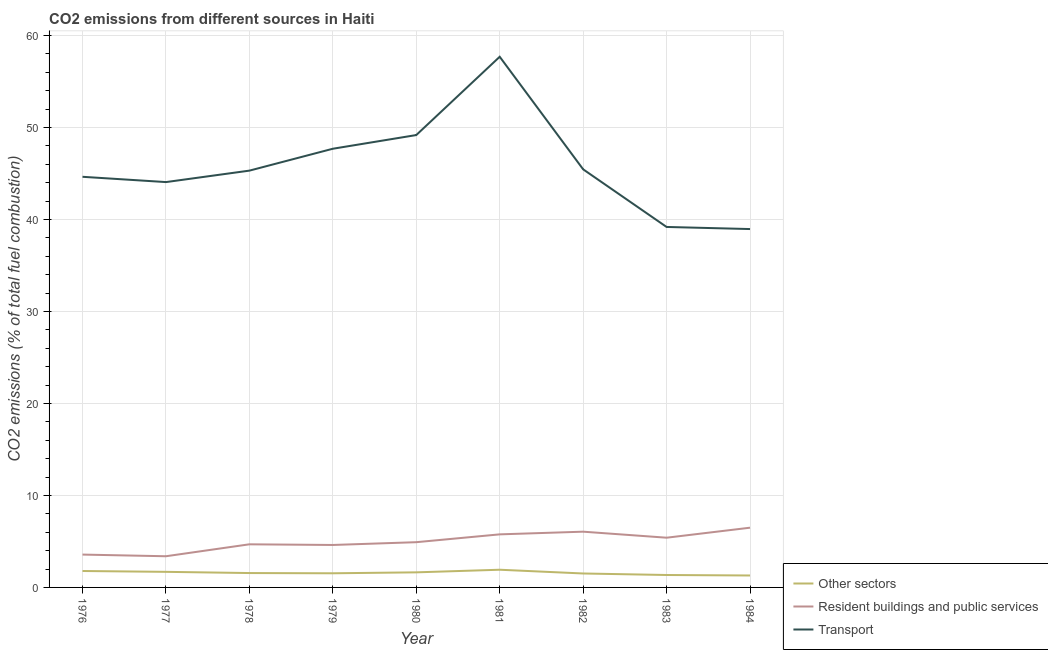Does the line corresponding to percentage of co2 emissions from other sectors intersect with the line corresponding to percentage of co2 emissions from resident buildings and public services?
Your response must be concise. No. What is the percentage of co2 emissions from other sectors in 1983?
Ensure brevity in your answer.  1.35. Across all years, what is the maximum percentage of co2 emissions from other sectors?
Your answer should be compact. 1.92. Across all years, what is the minimum percentage of co2 emissions from resident buildings and public services?
Provide a succinct answer. 3.39. In which year was the percentage of co2 emissions from resident buildings and public services maximum?
Make the answer very short. 1984. What is the total percentage of co2 emissions from other sectors in the graph?
Offer a terse response. 14.31. What is the difference between the percentage of co2 emissions from other sectors in 1977 and that in 1980?
Your answer should be very brief. 0.06. What is the difference between the percentage of co2 emissions from resident buildings and public services in 1983 and the percentage of co2 emissions from transport in 1977?
Give a very brief answer. -38.66. What is the average percentage of co2 emissions from transport per year?
Offer a very short reply. 45.8. In the year 1982, what is the difference between the percentage of co2 emissions from resident buildings and public services and percentage of co2 emissions from transport?
Give a very brief answer. -39.39. In how many years, is the percentage of co2 emissions from transport greater than 42 %?
Your answer should be compact. 7. What is the ratio of the percentage of co2 emissions from resident buildings and public services in 1976 to that in 1980?
Your answer should be compact. 0.73. Is the percentage of co2 emissions from resident buildings and public services in 1976 less than that in 1981?
Ensure brevity in your answer.  Yes. What is the difference between the highest and the second highest percentage of co2 emissions from resident buildings and public services?
Your response must be concise. 0.43. What is the difference between the highest and the lowest percentage of co2 emissions from transport?
Your response must be concise. 18.73. In how many years, is the percentage of co2 emissions from transport greater than the average percentage of co2 emissions from transport taken over all years?
Keep it short and to the point. 3. Is the sum of the percentage of co2 emissions from resident buildings and public services in 1976 and 1978 greater than the maximum percentage of co2 emissions from other sectors across all years?
Your response must be concise. Yes. Is the percentage of co2 emissions from transport strictly greater than the percentage of co2 emissions from resident buildings and public services over the years?
Provide a short and direct response. Yes. Is the percentage of co2 emissions from resident buildings and public services strictly less than the percentage of co2 emissions from other sectors over the years?
Keep it short and to the point. No. Where does the legend appear in the graph?
Make the answer very short. Bottom right. How many legend labels are there?
Offer a very short reply. 3. What is the title of the graph?
Ensure brevity in your answer.  CO2 emissions from different sources in Haiti. What is the label or title of the Y-axis?
Your answer should be compact. CO2 emissions (% of total fuel combustion). What is the CO2 emissions (% of total fuel combustion) in Other sectors in 1976?
Offer a very short reply. 1.79. What is the CO2 emissions (% of total fuel combustion) in Resident buildings and public services in 1976?
Keep it short and to the point. 3.57. What is the CO2 emissions (% of total fuel combustion) in Transport in 1976?
Give a very brief answer. 44.64. What is the CO2 emissions (% of total fuel combustion) in Other sectors in 1977?
Your response must be concise. 1.69. What is the CO2 emissions (% of total fuel combustion) in Resident buildings and public services in 1977?
Offer a terse response. 3.39. What is the CO2 emissions (% of total fuel combustion) in Transport in 1977?
Ensure brevity in your answer.  44.07. What is the CO2 emissions (% of total fuel combustion) in Other sectors in 1978?
Your response must be concise. 1.56. What is the CO2 emissions (% of total fuel combustion) of Resident buildings and public services in 1978?
Ensure brevity in your answer.  4.69. What is the CO2 emissions (% of total fuel combustion) in Transport in 1978?
Ensure brevity in your answer.  45.31. What is the CO2 emissions (% of total fuel combustion) of Other sectors in 1979?
Your answer should be very brief. 1.54. What is the CO2 emissions (% of total fuel combustion) of Resident buildings and public services in 1979?
Provide a short and direct response. 4.62. What is the CO2 emissions (% of total fuel combustion) of Transport in 1979?
Keep it short and to the point. 47.69. What is the CO2 emissions (% of total fuel combustion) in Other sectors in 1980?
Offer a terse response. 1.64. What is the CO2 emissions (% of total fuel combustion) in Resident buildings and public services in 1980?
Provide a short and direct response. 4.92. What is the CO2 emissions (% of total fuel combustion) of Transport in 1980?
Your response must be concise. 49.18. What is the CO2 emissions (% of total fuel combustion) in Other sectors in 1981?
Give a very brief answer. 1.92. What is the CO2 emissions (% of total fuel combustion) of Resident buildings and public services in 1981?
Make the answer very short. 5.77. What is the CO2 emissions (% of total fuel combustion) of Transport in 1981?
Your answer should be compact. 57.69. What is the CO2 emissions (% of total fuel combustion) of Other sectors in 1982?
Offer a very short reply. 1.52. What is the CO2 emissions (% of total fuel combustion) of Resident buildings and public services in 1982?
Ensure brevity in your answer.  6.06. What is the CO2 emissions (% of total fuel combustion) of Transport in 1982?
Your response must be concise. 45.45. What is the CO2 emissions (% of total fuel combustion) of Other sectors in 1983?
Offer a very short reply. 1.35. What is the CO2 emissions (% of total fuel combustion) of Resident buildings and public services in 1983?
Make the answer very short. 5.41. What is the CO2 emissions (% of total fuel combustion) of Transport in 1983?
Make the answer very short. 39.19. What is the CO2 emissions (% of total fuel combustion) in Other sectors in 1984?
Offer a terse response. 1.3. What is the CO2 emissions (% of total fuel combustion) of Resident buildings and public services in 1984?
Give a very brief answer. 6.49. What is the CO2 emissions (% of total fuel combustion) in Transport in 1984?
Give a very brief answer. 38.96. Across all years, what is the maximum CO2 emissions (% of total fuel combustion) in Other sectors?
Your response must be concise. 1.92. Across all years, what is the maximum CO2 emissions (% of total fuel combustion) in Resident buildings and public services?
Give a very brief answer. 6.49. Across all years, what is the maximum CO2 emissions (% of total fuel combustion) in Transport?
Provide a succinct answer. 57.69. Across all years, what is the minimum CO2 emissions (% of total fuel combustion) of Other sectors?
Ensure brevity in your answer.  1.3. Across all years, what is the minimum CO2 emissions (% of total fuel combustion) in Resident buildings and public services?
Give a very brief answer. 3.39. Across all years, what is the minimum CO2 emissions (% of total fuel combustion) of Transport?
Give a very brief answer. 38.96. What is the total CO2 emissions (% of total fuel combustion) of Other sectors in the graph?
Your answer should be very brief. 14.31. What is the total CO2 emissions (% of total fuel combustion) of Resident buildings and public services in the graph?
Provide a short and direct response. 44.91. What is the total CO2 emissions (% of total fuel combustion) of Transport in the graph?
Your response must be concise. 412.19. What is the difference between the CO2 emissions (% of total fuel combustion) in Other sectors in 1976 and that in 1977?
Offer a very short reply. 0.09. What is the difference between the CO2 emissions (% of total fuel combustion) of Resident buildings and public services in 1976 and that in 1977?
Keep it short and to the point. 0.18. What is the difference between the CO2 emissions (% of total fuel combustion) of Transport in 1976 and that in 1977?
Give a very brief answer. 0.58. What is the difference between the CO2 emissions (% of total fuel combustion) of Other sectors in 1976 and that in 1978?
Keep it short and to the point. 0.22. What is the difference between the CO2 emissions (% of total fuel combustion) of Resident buildings and public services in 1976 and that in 1978?
Provide a succinct answer. -1.12. What is the difference between the CO2 emissions (% of total fuel combustion) of Transport in 1976 and that in 1978?
Your answer should be compact. -0.67. What is the difference between the CO2 emissions (% of total fuel combustion) of Other sectors in 1976 and that in 1979?
Ensure brevity in your answer.  0.25. What is the difference between the CO2 emissions (% of total fuel combustion) in Resident buildings and public services in 1976 and that in 1979?
Provide a succinct answer. -1.04. What is the difference between the CO2 emissions (% of total fuel combustion) of Transport in 1976 and that in 1979?
Make the answer very short. -3.05. What is the difference between the CO2 emissions (% of total fuel combustion) in Other sectors in 1976 and that in 1980?
Your response must be concise. 0.15. What is the difference between the CO2 emissions (% of total fuel combustion) of Resident buildings and public services in 1976 and that in 1980?
Make the answer very short. -1.35. What is the difference between the CO2 emissions (% of total fuel combustion) in Transport in 1976 and that in 1980?
Give a very brief answer. -4.54. What is the difference between the CO2 emissions (% of total fuel combustion) in Other sectors in 1976 and that in 1981?
Make the answer very short. -0.14. What is the difference between the CO2 emissions (% of total fuel combustion) of Resident buildings and public services in 1976 and that in 1981?
Your response must be concise. -2.2. What is the difference between the CO2 emissions (% of total fuel combustion) in Transport in 1976 and that in 1981?
Provide a succinct answer. -13.05. What is the difference between the CO2 emissions (% of total fuel combustion) in Other sectors in 1976 and that in 1982?
Keep it short and to the point. 0.27. What is the difference between the CO2 emissions (% of total fuel combustion) of Resident buildings and public services in 1976 and that in 1982?
Offer a terse response. -2.49. What is the difference between the CO2 emissions (% of total fuel combustion) in Transport in 1976 and that in 1982?
Your answer should be compact. -0.81. What is the difference between the CO2 emissions (% of total fuel combustion) of Other sectors in 1976 and that in 1983?
Give a very brief answer. 0.43. What is the difference between the CO2 emissions (% of total fuel combustion) in Resident buildings and public services in 1976 and that in 1983?
Offer a terse response. -1.83. What is the difference between the CO2 emissions (% of total fuel combustion) of Transport in 1976 and that in 1983?
Make the answer very short. 5.45. What is the difference between the CO2 emissions (% of total fuel combustion) in Other sectors in 1976 and that in 1984?
Give a very brief answer. 0.49. What is the difference between the CO2 emissions (% of total fuel combustion) of Resident buildings and public services in 1976 and that in 1984?
Provide a succinct answer. -2.92. What is the difference between the CO2 emissions (% of total fuel combustion) of Transport in 1976 and that in 1984?
Offer a very short reply. 5.68. What is the difference between the CO2 emissions (% of total fuel combustion) in Other sectors in 1977 and that in 1978?
Provide a short and direct response. 0.13. What is the difference between the CO2 emissions (% of total fuel combustion) of Resident buildings and public services in 1977 and that in 1978?
Offer a very short reply. -1.3. What is the difference between the CO2 emissions (% of total fuel combustion) of Transport in 1977 and that in 1978?
Make the answer very short. -1.24. What is the difference between the CO2 emissions (% of total fuel combustion) in Other sectors in 1977 and that in 1979?
Your answer should be compact. 0.16. What is the difference between the CO2 emissions (% of total fuel combustion) in Resident buildings and public services in 1977 and that in 1979?
Provide a short and direct response. -1.23. What is the difference between the CO2 emissions (% of total fuel combustion) of Transport in 1977 and that in 1979?
Your response must be concise. -3.62. What is the difference between the CO2 emissions (% of total fuel combustion) in Other sectors in 1977 and that in 1980?
Your answer should be very brief. 0.06. What is the difference between the CO2 emissions (% of total fuel combustion) of Resident buildings and public services in 1977 and that in 1980?
Offer a terse response. -1.53. What is the difference between the CO2 emissions (% of total fuel combustion) of Transport in 1977 and that in 1980?
Keep it short and to the point. -5.11. What is the difference between the CO2 emissions (% of total fuel combustion) in Other sectors in 1977 and that in 1981?
Provide a succinct answer. -0.23. What is the difference between the CO2 emissions (% of total fuel combustion) of Resident buildings and public services in 1977 and that in 1981?
Ensure brevity in your answer.  -2.38. What is the difference between the CO2 emissions (% of total fuel combustion) in Transport in 1977 and that in 1981?
Offer a terse response. -13.62. What is the difference between the CO2 emissions (% of total fuel combustion) of Other sectors in 1977 and that in 1982?
Provide a succinct answer. 0.18. What is the difference between the CO2 emissions (% of total fuel combustion) in Resident buildings and public services in 1977 and that in 1982?
Your response must be concise. -2.67. What is the difference between the CO2 emissions (% of total fuel combustion) of Transport in 1977 and that in 1982?
Provide a succinct answer. -1.39. What is the difference between the CO2 emissions (% of total fuel combustion) of Other sectors in 1977 and that in 1983?
Your response must be concise. 0.34. What is the difference between the CO2 emissions (% of total fuel combustion) of Resident buildings and public services in 1977 and that in 1983?
Make the answer very short. -2.02. What is the difference between the CO2 emissions (% of total fuel combustion) of Transport in 1977 and that in 1983?
Your answer should be compact. 4.88. What is the difference between the CO2 emissions (% of total fuel combustion) in Other sectors in 1977 and that in 1984?
Give a very brief answer. 0.4. What is the difference between the CO2 emissions (% of total fuel combustion) of Resident buildings and public services in 1977 and that in 1984?
Ensure brevity in your answer.  -3.1. What is the difference between the CO2 emissions (% of total fuel combustion) in Transport in 1977 and that in 1984?
Offer a terse response. 5.11. What is the difference between the CO2 emissions (% of total fuel combustion) of Other sectors in 1978 and that in 1979?
Give a very brief answer. 0.02. What is the difference between the CO2 emissions (% of total fuel combustion) of Resident buildings and public services in 1978 and that in 1979?
Offer a terse response. 0.07. What is the difference between the CO2 emissions (% of total fuel combustion) of Transport in 1978 and that in 1979?
Give a very brief answer. -2.38. What is the difference between the CO2 emissions (% of total fuel combustion) in Other sectors in 1978 and that in 1980?
Provide a succinct answer. -0.08. What is the difference between the CO2 emissions (% of total fuel combustion) of Resident buildings and public services in 1978 and that in 1980?
Offer a very short reply. -0.23. What is the difference between the CO2 emissions (% of total fuel combustion) in Transport in 1978 and that in 1980?
Make the answer very short. -3.87. What is the difference between the CO2 emissions (% of total fuel combustion) in Other sectors in 1978 and that in 1981?
Ensure brevity in your answer.  -0.36. What is the difference between the CO2 emissions (% of total fuel combustion) of Resident buildings and public services in 1978 and that in 1981?
Your answer should be very brief. -1.08. What is the difference between the CO2 emissions (% of total fuel combustion) in Transport in 1978 and that in 1981?
Keep it short and to the point. -12.38. What is the difference between the CO2 emissions (% of total fuel combustion) in Other sectors in 1978 and that in 1982?
Make the answer very short. 0.05. What is the difference between the CO2 emissions (% of total fuel combustion) in Resident buildings and public services in 1978 and that in 1982?
Ensure brevity in your answer.  -1.37. What is the difference between the CO2 emissions (% of total fuel combustion) of Transport in 1978 and that in 1982?
Offer a very short reply. -0.14. What is the difference between the CO2 emissions (% of total fuel combustion) in Other sectors in 1978 and that in 1983?
Provide a succinct answer. 0.21. What is the difference between the CO2 emissions (% of total fuel combustion) in Resident buildings and public services in 1978 and that in 1983?
Ensure brevity in your answer.  -0.72. What is the difference between the CO2 emissions (% of total fuel combustion) in Transport in 1978 and that in 1983?
Offer a very short reply. 6.12. What is the difference between the CO2 emissions (% of total fuel combustion) in Other sectors in 1978 and that in 1984?
Make the answer very short. 0.26. What is the difference between the CO2 emissions (% of total fuel combustion) in Resident buildings and public services in 1978 and that in 1984?
Your answer should be compact. -1.81. What is the difference between the CO2 emissions (% of total fuel combustion) of Transport in 1978 and that in 1984?
Your response must be concise. 6.35. What is the difference between the CO2 emissions (% of total fuel combustion) of Other sectors in 1979 and that in 1980?
Provide a short and direct response. -0.1. What is the difference between the CO2 emissions (% of total fuel combustion) of Resident buildings and public services in 1979 and that in 1980?
Make the answer very short. -0.3. What is the difference between the CO2 emissions (% of total fuel combustion) of Transport in 1979 and that in 1980?
Your response must be concise. -1.49. What is the difference between the CO2 emissions (% of total fuel combustion) of Other sectors in 1979 and that in 1981?
Ensure brevity in your answer.  -0.38. What is the difference between the CO2 emissions (% of total fuel combustion) of Resident buildings and public services in 1979 and that in 1981?
Make the answer very short. -1.15. What is the difference between the CO2 emissions (% of total fuel combustion) in Other sectors in 1979 and that in 1982?
Offer a terse response. 0.02. What is the difference between the CO2 emissions (% of total fuel combustion) in Resident buildings and public services in 1979 and that in 1982?
Offer a terse response. -1.45. What is the difference between the CO2 emissions (% of total fuel combustion) of Transport in 1979 and that in 1982?
Keep it short and to the point. 2.24. What is the difference between the CO2 emissions (% of total fuel combustion) in Other sectors in 1979 and that in 1983?
Give a very brief answer. 0.19. What is the difference between the CO2 emissions (% of total fuel combustion) of Resident buildings and public services in 1979 and that in 1983?
Your answer should be very brief. -0.79. What is the difference between the CO2 emissions (% of total fuel combustion) of Transport in 1979 and that in 1983?
Offer a terse response. 8.5. What is the difference between the CO2 emissions (% of total fuel combustion) of Other sectors in 1979 and that in 1984?
Your answer should be compact. 0.24. What is the difference between the CO2 emissions (% of total fuel combustion) in Resident buildings and public services in 1979 and that in 1984?
Keep it short and to the point. -1.88. What is the difference between the CO2 emissions (% of total fuel combustion) of Transport in 1979 and that in 1984?
Ensure brevity in your answer.  8.73. What is the difference between the CO2 emissions (% of total fuel combustion) in Other sectors in 1980 and that in 1981?
Your response must be concise. -0.28. What is the difference between the CO2 emissions (% of total fuel combustion) in Resident buildings and public services in 1980 and that in 1981?
Provide a short and direct response. -0.85. What is the difference between the CO2 emissions (% of total fuel combustion) of Transport in 1980 and that in 1981?
Keep it short and to the point. -8.51. What is the difference between the CO2 emissions (% of total fuel combustion) in Other sectors in 1980 and that in 1982?
Keep it short and to the point. 0.12. What is the difference between the CO2 emissions (% of total fuel combustion) in Resident buildings and public services in 1980 and that in 1982?
Your response must be concise. -1.14. What is the difference between the CO2 emissions (% of total fuel combustion) of Transport in 1980 and that in 1982?
Give a very brief answer. 3.73. What is the difference between the CO2 emissions (% of total fuel combustion) of Other sectors in 1980 and that in 1983?
Your response must be concise. 0.29. What is the difference between the CO2 emissions (% of total fuel combustion) in Resident buildings and public services in 1980 and that in 1983?
Ensure brevity in your answer.  -0.49. What is the difference between the CO2 emissions (% of total fuel combustion) of Transport in 1980 and that in 1983?
Your response must be concise. 9.99. What is the difference between the CO2 emissions (% of total fuel combustion) of Other sectors in 1980 and that in 1984?
Offer a very short reply. 0.34. What is the difference between the CO2 emissions (% of total fuel combustion) of Resident buildings and public services in 1980 and that in 1984?
Provide a succinct answer. -1.58. What is the difference between the CO2 emissions (% of total fuel combustion) of Transport in 1980 and that in 1984?
Provide a succinct answer. 10.22. What is the difference between the CO2 emissions (% of total fuel combustion) of Other sectors in 1981 and that in 1982?
Give a very brief answer. 0.41. What is the difference between the CO2 emissions (% of total fuel combustion) in Resident buildings and public services in 1981 and that in 1982?
Ensure brevity in your answer.  -0.29. What is the difference between the CO2 emissions (% of total fuel combustion) in Transport in 1981 and that in 1982?
Your response must be concise. 12.24. What is the difference between the CO2 emissions (% of total fuel combustion) in Other sectors in 1981 and that in 1983?
Your answer should be very brief. 0.57. What is the difference between the CO2 emissions (% of total fuel combustion) in Resident buildings and public services in 1981 and that in 1983?
Give a very brief answer. 0.36. What is the difference between the CO2 emissions (% of total fuel combustion) in Transport in 1981 and that in 1983?
Provide a succinct answer. 18.5. What is the difference between the CO2 emissions (% of total fuel combustion) of Other sectors in 1981 and that in 1984?
Give a very brief answer. 0.62. What is the difference between the CO2 emissions (% of total fuel combustion) of Resident buildings and public services in 1981 and that in 1984?
Keep it short and to the point. -0.72. What is the difference between the CO2 emissions (% of total fuel combustion) in Transport in 1981 and that in 1984?
Offer a terse response. 18.73. What is the difference between the CO2 emissions (% of total fuel combustion) of Other sectors in 1982 and that in 1983?
Provide a succinct answer. 0.16. What is the difference between the CO2 emissions (% of total fuel combustion) in Resident buildings and public services in 1982 and that in 1983?
Offer a very short reply. 0.66. What is the difference between the CO2 emissions (% of total fuel combustion) of Transport in 1982 and that in 1983?
Your answer should be compact. 6.27. What is the difference between the CO2 emissions (% of total fuel combustion) of Other sectors in 1982 and that in 1984?
Your response must be concise. 0.22. What is the difference between the CO2 emissions (% of total fuel combustion) of Resident buildings and public services in 1982 and that in 1984?
Your answer should be compact. -0.43. What is the difference between the CO2 emissions (% of total fuel combustion) of Transport in 1982 and that in 1984?
Keep it short and to the point. 6.49. What is the difference between the CO2 emissions (% of total fuel combustion) of Other sectors in 1983 and that in 1984?
Offer a terse response. 0.05. What is the difference between the CO2 emissions (% of total fuel combustion) of Resident buildings and public services in 1983 and that in 1984?
Ensure brevity in your answer.  -1.09. What is the difference between the CO2 emissions (% of total fuel combustion) of Transport in 1983 and that in 1984?
Your answer should be compact. 0.23. What is the difference between the CO2 emissions (% of total fuel combustion) of Other sectors in 1976 and the CO2 emissions (% of total fuel combustion) of Resident buildings and public services in 1977?
Your answer should be very brief. -1.6. What is the difference between the CO2 emissions (% of total fuel combustion) in Other sectors in 1976 and the CO2 emissions (% of total fuel combustion) in Transport in 1977?
Your answer should be compact. -42.28. What is the difference between the CO2 emissions (% of total fuel combustion) of Resident buildings and public services in 1976 and the CO2 emissions (% of total fuel combustion) of Transport in 1977?
Your answer should be compact. -40.5. What is the difference between the CO2 emissions (% of total fuel combustion) in Other sectors in 1976 and the CO2 emissions (% of total fuel combustion) in Resident buildings and public services in 1978?
Your answer should be very brief. -2.9. What is the difference between the CO2 emissions (% of total fuel combustion) in Other sectors in 1976 and the CO2 emissions (% of total fuel combustion) in Transport in 1978?
Keep it short and to the point. -43.53. What is the difference between the CO2 emissions (% of total fuel combustion) in Resident buildings and public services in 1976 and the CO2 emissions (% of total fuel combustion) in Transport in 1978?
Give a very brief answer. -41.74. What is the difference between the CO2 emissions (% of total fuel combustion) in Other sectors in 1976 and the CO2 emissions (% of total fuel combustion) in Resident buildings and public services in 1979?
Keep it short and to the point. -2.83. What is the difference between the CO2 emissions (% of total fuel combustion) in Other sectors in 1976 and the CO2 emissions (% of total fuel combustion) in Transport in 1979?
Make the answer very short. -45.91. What is the difference between the CO2 emissions (% of total fuel combustion) in Resident buildings and public services in 1976 and the CO2 emissions (% of total fuel combustion) in Transport in 1979?
Your answer should be very brief. -44.12. What is the difference between the CO2 emissions (% of total fuel combustion) of Other sectors in 1976 and the CO2 emissions (% of total fuel combustion) of Resident buildings and public services in 1980?
Provide a short and direct response. -3.13. What is the difference between the CO2 emissions (% of total fuel combustion) of Other sectors in 1976 and the CO2 emissions (% of total fuel combustion) of Transport in 1980?
Ensure brevity in your answer.  -47.39. What is the difference between the CO2 emissions (% of total fuel combustion) in Resident buildings and public services in 1976 and the CO2 emissions (% of total fuel combustion) in Transport in 1980?
Provide a short and direct response. -45.61. What is the difference between the CO2 emissions (% of total fuel combustion) of Other sectors in 1976 and the CO2 emissions (% of total fuel combustion) of Resident buildings and public services in 1981?
Your answer should be very brief. -3.98. What is the difference between the CO2 emissions (% of total fuel combustion) of Other sectors in 1976 and the CO2 emissions (% of total fuel combustion) of Transport in 1981?
Offer a very short reply. -55.91. What is the difference between the CO2 emissions (% of total fuel combustion) in Resident buildings and public services in 1976 and the CO2 emissions (% of total fuel combustion) in Transport in 1981?
Keep it short and to the point. -54.12. What is the difference between the CO2 emissions (% of total fuel combustion) in Other sectors in 1976 and the CO2 emissions (% of total fuel combustion) in Resident buildings and public services in 1982?
Your answer should be compact. -4.27. What is the difference between the CO2 emissions (% of total fuel combustion) of Other sectors in 1976 and the CO2 emissions (% of total fuel combustion) of Transport in 1982?
Offer a terse response. -43.67. What is the difference between the CO2 emissions (% of total fuel combustion) in Resident buildings and public services in 1976 and the CO2 emissions (% of total fuel combustion) in Transport in 1982?
Your response must be concise. -41.88. What is the difference between the CO2 emissions (% of total fuel combustion) in Other sectors in 1976 and the CO2 emissions (% of total fuel combustion) in Resident buildings and public services in 1983?
Give a very brief answer. -3.62. What is the difference between the CO2 emissions (% of total fuel combustion) in Other sectors in 1976 and the CO2 emissions (% of total fuel combustion) in Transport in 1983?
Give a very brief answer. -37.4. What is the difference between the CO2 emissions (% of total fuel combustion) in Resident buildings and public services in 1976 and the CO2 emissions (% of total fuel combustion) in Transport in 1983?
Your response must be concise. -35.62. What is the difference between the CO2 emissions (% of total fuel combustion) of Other sectors in 1976 and the CO2 emissions (% of total fuel combustion) of Resident buildings and public services in 1984?
Provide a succinct answer. -4.71. What is the difference between the CO2 emissions (% of total fuel combustion) of Other sectors in 1976 and the CO2 emissions (% of total fuel combustion) of Transport in 1984?
Offer a very short reply. -37.18. What is the difference between the CO2 emissions (% of total fuel combustion) in Resident buildings and public services in 1976 and the CO2 emissions (% of total fuel combustion) in Transport in 1984?
Offer a terse response. -35.39. What is the difference between the CO2 emissions (% of total fuel combustion) of Other sectors in 1977 and the CO2 emissions (% of total fuel combustion) of Resident buildings and public services in 1978?
Give a very brief answer. -2.99. What is the difference between the CO2 emissions (% of total fuel combustion) in Other sectors in 1977 and the CO2 emissions (% of total fuel combustion) in Transport in 1978?
Your answer should be compact. -43.62. What is the difference between the CO2 emissions (% of total fuel combustion) in Resident buildings and public services in 1977 and the CO2 emissions (% of total fuel combustion) in Transport in 1978?
Offer a terse response. -41.92. What is the difference between the CO2 emissions (% of total fuel combustion) in Other sectors in 1977 and the CO2 emissions (% of total fuel combustion) in Resident buildings and public services in 1979?
Offer a terse response. -2.92. What is the difference between the CO2 emissions (% of total fuel combustion) of Other sectors in 1977 and the CO2 emissions (% of total fuel combustion) of Transport in 1979?
Give a very brief answer. -46. What is the difference between the CO2 emissions (% of total fuel combustion) in Resident buildings and public services in 1977 and the CO2 emissions (% of total fuel combustion) in Transport in 1979?
Offer a very short reply. -44.3. What is the difference between the CO2 emissions (% of total fuel combustion) in Other sectors in 1977 and the CO2 emissions (% of total fuel combustion) in Resident buildings and public services in 1980?
Your answer should be compact. -3.22. What is the difference between the CO2 emissions (% of total fuel combustion) in Other sectors in 1977 and the CO2 emissions (% of total fuel combustion) in Transport in 1980?
Ensure brevity in your answer.  -47.49. What is the difference between the CO2 emissions (% of total fuel combustion) in Resident buildings and public services in 1977 and the CO2 emissions (% of total fuel combustion) in Transport in 1980?
Provide a succinct answer. -45.79. What is the difference between the CO2 emissions (% of total fuel combustion) in Other sectors in 1977 and the CO2 emissions (% of total fuel combustion) in Resident buildings and public services in 1981?
Keep it short and to the point. -4.07. What is the difference between the CO2 emissions (% of total fuel combustion) in Other sectors in 1977 and the CO2 emissions (% of total fuel combustion) in Transport in 1981?
Offer a terse response. -56. What is the difference between the CO2 emissions (% of total fuel combustion) of Resident buildings and public services in 1977 and the CO2 emissions (% of total fuel combustion) of Transport in 1981?
Your answer should be compact. -54.3. What is the difference between the CO2 emissions (% of total fuel combustion) in Other sectors in 1977 and the CO2 emissions (% of total fuel combustion) in Resident buildings and public services in 1982?
Make the answer very short. -4.37. What is the difference between the CO2 emissions (% of total fuel combustion) in Other sectors in 1977 and the CO2 emissions (% of total fuel combustion) in Transport in 1982?
Offer a very short reply. -43.76. What is the difference between the CO2 emissions (% of total fuel combustion) of Resident buildings and public services in 1977 and the CO2 emissions (% of total fuel combustion) of Transport in 1982?
Provide a succinct answer. -42.06. What is the difference between the CO2 emissions (% of total fuel combustion) in Other sectors in 1977 and the CO2 emissions (% of total fuel combustion) in Resident buildings and public services in 1983?
Make the answer very short. -3.71. What is the difference between the CO2 emissions (% of total fuel combustion) of Other sectors in 1977 and the CO2 emissions (% of total fuel combustion) of Transport in 1983?
Provide a short and direct response. -37.49. What is the difference between the CO2 emissions (% of total fuel combustion) of Resident buildings and public services in 1977 and the CO2 emissions (% of total fuel combustion) of Transport in 1983?
Make the answer very short. -35.8. What is the difference between the CO2 emissions (% of total fuel combustion) in Other sectors in 1977 and the CO2 emissions (% of total fuel combustion) in Resident buildings and public services in 1984?
Give a very brief answer. -4.8. What is the difference between the CO2 emissions (% of total fuel combustion) in Other sectors in 1977 and the CO2 emissions (% of total fuel combustion) in Transport in 1984?
Your answer should be compact. -37.27. What is the difference between the CO2 emissions (% of total fuel combustion) in Resident buildings and public services in 1977 and the CO2 emissions (% of total fuel combustion) in Transport in 1984?
Give a very brief answer. -35.57. What is the difference between the CO2 emissions (% of total fuel combustion) of Other sectors in 1978 and the CO2 emissions (% of total fuel combustion) of Resident buildings and public services in 1979?
Make the answer very short. -3.05. What is the difference between the CO2 emissions (% of total fuel combustion) of Other sectors in 1978 and the CO2 emissions (% of total fuel combustion) of Transport in 1979?
Your response must be concise. -46.13. What is the difference between the CO2 emissions (% of total fuel combustion) of Resident buildings and public services in 1978 and the CO2 emissions (% of total fuel combustion) of Transport in 1979?
Keep it short and to the point. -43. What is the difference between the CO2 emissions (% of total fuel combustion) of Other sectors in 1978 and the CO2 emissions (% of total fuel combustion) of Resident buildings and public services in 1980?
Give a very brief answer. -3.36. What is the difference between the CO2 emissions (% of total fuel combustion) in Other sectors in 1978 and the CO2 emissions (% of total fuel combustion) in Transport in 1980?
Keep it short and to the point. -47.62. What is the difference between the CO2 emissions (% of total fuel combustion) of Resident buildings and public services in 1978 and the CO2 emissions (% of total fuel combustion) of Transport in 1980?
Your response must be concise. -44.49. What is the difference between the CO2 emissions (% of total fuel combustion) of Other sectors in 1978 and the CO2 emissions (% of total fuel combustion) of Resident buildings and public services in 1981?
Your response must be concise. -4.21. What is the difference between the CO2 emissions (% of total fuel combustion) in Other sectors in 1978 and the CO2 emissions (% of total fuel combustion) in Transport in 1981?
Offer a very short reply. -56.13. What is the difference between the CO2 emissions (% of total fuel combustion) of Resident buildings and public services in 1978 and the CO2 emissions (% of total fuel combustion) of Transport in 1981?
Provide a short and direct response. -53. What is the difference between the CO2 emissions (% of total fuel combustion) of Other sectors in 1978 and the CO2 emissions (% of total fuel combustion) of Resident buildings and public services in 1982?
Your answer should be very brief. -4.5. What is the difference between the CO2 emissions (% of total fuel combustion) of Other sectors in 1978 and the CO2 emissions (% of total fuel combustion) of Transport in 1982?
Your answer should be very brief. -43.89. What is the difference between the CO2 emissions (% of total fuel combustion) of Resident buildings and public services in 1978 and the CO2 emissions (% of total fuel combustion) of Transport in 1982?
Keep it short and to the point. -40.77. What is the difference between the CO2 emissions (% of total fuel combustion) in Other sectors in 1978 and the CO2 emissions (% of total fuel combustion) in Resident buildings and public services in 1983?
Provide a succinct answer. -3.84. What is the difference between the CO2 emissions (% of total fuel combustion) in Other sectors in 1978 and the CO2 emissions (% of total fuel combustion) in Transport in 1983?
Provide a succinct answer. -37.63. What is the difference between the CO2 emissions (% of total fuel combustion) of Resident buildings and public services in 1978 and the CO2 emissions (% of total fuel combustion) of Transport in 1983?
Keep it short and to the point. -34.5. What is the difference between the CO2 emissions (% of total fuel combustion) in Other sectors in 1978 and the CO2 emissions (% of total fuel combustion) in Resident buildings and public services in 1984?
Ensure brevity in your answer.  -4.93. What is the difference between the CO2 emissions (% of total fuel combustion) in Other sectors in 1978 and the CO2 emissions (% of total fuel combustion) in Transport in 1984?
Your answer should be very brief. -37.4. What is the difference between the CO2 emissions (% of total fuel combustion) in Resident buildings and public services in 1978 and the CO2 emissions (% of total fuel combustion) in Transport in 1984?
Ensure brevity in your answer.  -34.27. What is the difference between the CO2 emissions (% of total fuel combustion) in Other sectors in 1979 and the CO2 emissions (% of total fuel combustion) in Resident buildings and public services in 1980?
Your answer should be compact. -3.38. What is the difference between the CO2 emissions (% of total fuel combustion) of Other sectors in 1979 and the CO2 emissions (% of total fuel combustion) of Transport in 1980?
Your answer should be very brief. -47.64. What is the difference between the CO2 emissions (% of total fuel combustion) of Resident buildings and public services in 1979 and the CO2 emissions (% of total fuel combustion) of Transport in 1980?
Offer a very short reply. -44.56. What is the difference between the CO2 emissions (% of total fuel combustion) of Other sectors in 1979 and the CO2 emissions (% of total fuel combustion) of Resident buildings and public services in 1981?
Offer a terse response. -4.23. What is the difference between the CO2 emissions (% of total fuel combustion) in Other sectors in 1979 and the CO2 emissions (% of total fuel combustion) in Transport in 1981?
Your answer should be compact. -56.15. What is the difference between the CO2 emissions (% of total fuel combustion) in Resident buildings and public services in 1979 and the CO2 emissions (% of total fuel combustion) in Transport in 1981?
Make the answer very short. -53.08. What is the difference between the CO2 emissions (% of total fuel combustion) of Other sectors in 1979 and the CO2 emissions (% of total fuel combustion) of Resident buildings and public services in 1982?
Offer a terse response. -4.52. What is the difference between the CO2 emissions (% of total fuel combustion) in Other sectors in 1979 and the CO2 emissions (% of total fuel combustion) in Transport in 1982?
Keep it short and to the point. -43.92. What is the difference between the CO2 emissions (% of total fuel combustion) in Resident buildings and public services in 1979 and the CO2 emissions (% of total fuel combustion) in Transport in 1982?
Keep it short and to the point. -40.84. What is the difference between the CO2 emissions (% of total fuel combustion) in Other sectors in 1979 and the CO2 emissions (% of total fuel combustion) in Resident buildings and public services in 1983?
Provide a succinct answer. -3.87. What is the difference between the CO2 emissions (% of total fuel combustion) of Other sectors in 1979 and the CO2 emissions (% of total fuel combustion) of Transport in 1983?
Keep it short and to the point. -37.65. What is the difference between the CO2 emissions (% of total fuel combustion) in Resident buildings and public services in 1979 and the CO2 emissions (% of total fuel combustion) in Transport in 1983?
Offer a very short reply. -34.57. What is the difference between the CO2 emissions (% of total fuel combustion) of Other sectors in 1979 and the CO2 emissions (% of total fuel combustion) of Resident buildings and public services in 1984?
Offer a very short reply. -4.96. What is the difference between the CO2 emissions (% of total fuel combustion) in Other sectors in 1979 and the CO2 emissions (% of total fuel combustion) in Transport in 1984?
Make the answer very short. -37.42. What is the difference between the CO2 emissions (% of total fuel combustion) of Resident buildings and public services in 1979 and the CO2 emissions (% of total fuel combustion) of Transport in 1984?
Ensure brevity in your answer.  -34.35. What is the difference between the CO2 emissions (% of total fuel combustion) in Other sectors in 1980 and the CO2 emissions (% of total fuel combustion) in Resident buildings and public services in 1981?
Offer a terse response. -4.13. What is the difference between the CO2 emissions (% of total fuel combustion) in Other sectors in 1980 and the CO2 emissions (% of total fuel combustion) in Transport in 1981?
Your response must be concise. -56.05. What is the difference between the CO2 emissions (% of total fuel combustion) of Resident buildings and public services in 1980 and the CO2 emissions (% of total fuel combustion) of Transport in 1981?
Your answer should be very brief. -52.77. What is the difference between the CO2 emissions (% of total fuel combustion) of Other sectors in 1980 and the CO2 emissions (% of total fuel combustion) of Resident buildings and public services in 1982?
Your answer should be compact. -4.42. What is the difference between the CO2 emissions (% of total fuel combustion) of Other sectors in 1980 and the CO2 emissions (% of total fuel combustion) of Transport in 1982?
Provide a short and direct response. -43.82. What is the difference between the CO2 emissions (% of total fuel combustion) in Resident buildings and public services in 1980 and the CO2 emissions (% of total fuel combustion) in Transport in 1982?
Your answer should be very brief. -40.54. What is the difference between the CO2 emissions (% of total fuel combustion) in Other sectors in 1980 and the CO2 emissions (% of total fuel combustion) in Resident buildings and public services in 1983?
Make the answer very short. -3.77. What is the difference between the CO2 emissions (% of total fuel combustion) in Other sectors in 1980 and the CO2 emissions (% of total fuel combustion) in Transport in 1983?
Your answer should be compact. -37.55. What is the difference between the CO2 emissions (% of total fuel combustion) in Resident buildings and public services in 1980 and the CO2 emissions (% of total fuel combustion) in Transport in 1983?
Your response must be concise. -34.27. What is the difference between the CO2 emissions (% of total fuel combustion) in Other sectors in 1980 and the CO2 emissions (% of total fuel combustion) in Resident buildings and public services in 1984?
Provide a short and direct response. -4.85. What is the difference between the CO2 emissions (% of total fuel combustion) of Other sectors in 1980 and the CO2 emissions (% of total fuel combustion) of Transport in 1984?
Your answer should be very brief. -37.32. What is the difference between the CO2 emissions (% of total fuel combustion) in Resident buildings and public services in 1980 and the CO2 emissions (% of total fuel combustion) in Transport in 1984?
Provide a short and direct response. -34.04. What is the difference between the CO2 emissions (% of total fuel combustion) of Other sectors in 1981 and the CO2 emissions (% of total fuel combustion) of Resident buildings and public services in 1982?
Offer a very short reply. -4.14. What is the difference between the CO2 emissions (% of total fuel combustion) of Other sectors in 1981 and the CO2 emissions (% of total fuel combustion) of Transport in 1982?
Ensure brevity in your answer.  -43.53. What is the difference between the CO2 emissions (% of total fuel combustion) of Resident buildings and public services in 1981 and the CO2 emissions (% of total fuel combustion) of Transport in 1982?
Your response must be concise. -39.69. What is the difference between the CO2 emissions (% of total fuel combustion) of Other sectors in 1981 and the CO2 emissions (% of total fuel combustion) of Resident buildings and public services in 1983?
Your answer should be very brief. -3.48. What is the difference between the CO2 emissions (% of total fuel combustion) of Other sectors in 1981 and the CO2 emissions (% of total fuel combustion) of Transport in 1983?
Ensure brevity in your answer.  -37.27. What is the difference between the CO2 emissions (% of total fuel combustion) of Resident buildings and public services in 1981 and the CO2 emissions (% of total fuel combustion) of Transport in 1983?
Make the answer very short. -33.42. What is the difference between the CO2 emissions (% of total fuel combustion) in Other sectors in 1981 and the CO2 emissions (% of total fuel combustion) in Resident buildings and public services in 1984?
Give a very brief answer. -4.57. What is the difference between the CO2 emissions (% of total fuel combustion) in Other sectors in 1981 and the CO2 emissions (% of total fuel combustion) in Transport in 1984?
Ensure brevity in your answer.  -37.04. What is the difference between the CO2 emissions (% of total fuel combustion) of Resident buildings and public services in 1981 and the CO2 emissions (% of total fuel combustion) of Transport in 1984?
Provide a short and direct response. -33.19. What is the difference between the CO2 emissions (% of total fuel combustion) in Other sectors in 1982 and the CO2 emissions (% of total fuel combustion) in Resident buildings and public services in 1983?
Ensure brevity in your answer.  -3.89. What is the difference between the CO2 emissions (% of total fuel combustion) of Other sectors in 1982 and the CO2 emissions (% of total fuel combustion) of Transport in 1983?
Give a very brief answer. -37.67. What is the difference between the CO2 emissions (% of total fuel combustion) in Resident buildings and public services in 1982 and the CO2 emissions (% of total fuel combustion) in Transport in 1983?
Offer a terse response. -33.13. What is the difference between the CO2 emissions (% of total fuel combustion) in Other sectors in 1982 and the CO2 emissions (% of total fuel combustion) in Resident buildings and public services in 1984?
Make the answer very short. -4.98. What is the difference between the CO2 emissions (% of total fuel combustion) of Other sectors in 1982 and the CO2 emissions (% of total fuel combustion) of Transport in 1984?
Provide a short and direct response. -37.45. What is the difference between the CO2 emissions (% of total fuel combustion) of Resident buildings and public services in 1982 and the CO2 emissions (% of total fuel combustion) of Transport in 1984?
Make the answer very short. -32.9. What is the difference between the CO2 emissions (% of total fuel combustion) of Other sectors in 1983 and the CO2 emissions (% of total fuel combustion) of Resident buildings and public services in 1984?
Make the answer very short. -5.14. What is the difference between the CO2 emissions (% of total fuel combustion) in Other sectors in 1983 and the CO2 emissions (% of total fuel combustion) in Transport in 1984?
Make the answer very short. -37.61. What is the difference between the CO2 emissions (% of total fuel combustion) of Resident buildings and public services in 1983 and the CO2 emissions (% of total fuel combustion) of Transport in 1984?
Your answer should be compact. -33.56. What is the average CO2 emissions (% of total fuel combustion) in Other sectors per year?
Provide a succinct answer. 1.59. What is the average CO2 emissions (% of total fuel combustion) of Resident buildings and public services per year?
Provide a short and direct response. 4.99. What is the average CO2 emissions (% of total fuel combustion) of Transport per year?
Your response must be concise. 45.8. In the year 1976, what is the difference between the CO2 emissions (% of total fuel combustion) of Other sectors and CO2 emissions (% of total fuel combustion) of Resident buildings and public services?
Your answer should be compact. -1.79. In the year 1976, what is the difference between the CO2 emissions (% of total fuel combustion) in Other sectors and CO2 emissions (% of total fuel combustion) in Transport?
Provide a succinct answer. -42.86. In the year 1976, what is the difference between the CO2 emissions (% of total fuel combustion) of Resident buildings and public services and CO2 emissions (% of total fuel combustion) of Transport?
Offer a very short reply. -41.07. In the year 1977, what is the difference between the CO2 emissions (% of total fuel combustion) of Other sectors and CO2 emissions (% of total fuel combustion) of Resident buildings and public services?
Your response must be concise. -1.69. In the year 1977, what is the difference between the CO2 emissions (% of total fuel combustion) of Other sectors and CO2 emissions (% of total fuel combustion) of Transport?
Offer a very short reply. -42.37. In the year 1977, what is the difference between the CO2 emissions (% of total fuel combustion) in Resident buildings and public services and CO2 emissions (% of total fuel combustion) in Transport?
Your answer should be very brief. -40.68. In the year 1978, what is the difference between the CO2 emissions (% of total fuel combustion) in Other sectors and CO2 emissions (% of total fuel combustion) in Resident buildings and public services?
Give a very brief answer. -3.12. In the year 1978, what is the difference between the CO2 emissions (% of total fuel combustion) in Other sectors and CO2 emissions (% of total fuel combustion) in Transport?
Your answer should be very brief. -43.75. In the year 1978, what is the difference between the CO2 emissions (% of total fuel combustion) in Resident buildings and public services and CO2 emissions (% of total fuel combustion) in Transport?
Your response must be concise. -40.62. In the year 1979, what is the difference between the CO2 emissions (% of total fuel combustion) of Other sectors and CO2 emissions (% of total fuel combustion) of Resident buildings and public services?
Provide a succinct answer. -3.08. In the year 1979, what is the difference between the CO2 emissions (% of total fuel combustion) of Other sectors and CO2 emissions (% of total fuel combustion) of Transport?
Ensure brevity in your answer.  -46.15. In the year 1979, what is the difference between the CO2 emissions (% of total fuel combustion) of Resident buildings and public services and CO2 emissions (% of total fuel combustion) of Transport?
Ensure brevity in your answer.  -43.08. In the year 1980, what is the difference between the CO2 emissions (% of total fuel combustion) of Other sectors and CO2 emissions (% of total fuel combustion) of Resident buildings and public services?
Your answer should be compact. -3.28. In the year 1980, what is the difference between the CO2 emissions (% of total fuel combustion) of Other sectors and CO2 emissions (% of total fuel combustion) of Transport?
Make the answer very short. -47.54. In the year 1980, what is the difference between the CO2 emissions (% of total fuel combustion) in Resident buildings and public services and CO2 emissions (% of total fuel combustion) in Transport?
Give a very brief answer. -44.26. In the year 1981, what is the difference between the CO2 emissions (% of total fuel combustion) in Other sectors and CO2 emissions (% of total fuel combustion) in Resident buildings and public services?
Your answer should be compact. -3.85. In the year 1981, what is the difference between the CO2 emissions (% of total fuel combustion) in Other sectors and CO2 emissions (% of total fuel combustion) in Transport?
Your response must be concise. -55.77. In the year 1981, what is the difference between the CO2 emissions (% of total fuel combustion) of Resident buildings and public services and CO2 emissions (% of total fuel combustion) of Transport?
Ensure brevity in your answer.  -51.92. In the year 1982, what is the difference between the CO2 emissions (% of total fuel combustion) of Other sectors and CO2 emissions (% of total fuel combustion) of Resident buildings and public services?
Provide a succinct answer. -4.55. In the year 1982, what is the difference between the CO2 emissions (% of total fuel combustion) in Other sectors and CO2 emissions (% of total fuel combustion) in Transport?
Keep it short and to the point. -43.94. In the year 1982, what is the difference between the CO2 emissions (% of total fuel combustion) in Resident buildings and public services and CO2 emissions (% of total fuel combustion) in Transport?
Make the answer very short. -39.39. In the year 1983, what is the difference between the CO2 emissions (% of total fuel combustion) in Other sectors and CO2 emissions (% of total fuel combustion) in Resident buildings and public services?
Your answer should be compact. -4.05. In the year 1983, what is the difference between the CO2 emissions (% of total fuel combustion) in Other sectors and CO2 emissions (% of total fuel combustion) in Transport?
Your response must be concise. -37.84. In the year 1983, what is the difference between the CO2 emissions (% of total fuel combustion) of Resident buildings and public services and CO2 emissions (% of total fuel combustion) of Transport?
Your response must be concise. -33.78. In the year 1984, what is the difference between the CO2 emissions (% of total fuel combustion) in Other sectors and CO2 emissions (% of total fuel combustion) in Resident buildings and public services?
Your answer should be very brief. -5.19. In the year 1984, what is the difference between the CO2 emissions (% of total fuel combustion) in Other sectors and CO2 emissions (% of total fuel combustion) in Transport?
Offer a very short reply. -37.66. In the year 1984, what is the difference between the CO2 emissions (% of total fuel combustion) in Resident buildings and public services and CO2 emissions (% of total fuel combustion) in Transport?
Ensure brevity in your answer.  -32.47. What is the ratio of the CO2 emissions (% of total fuel combustion) of Other sectors in 1976 to that in 1977?
Your response must be concise. 1.05. What is the ratio of the CO2 emissions (% of total fuel combustion) of Resident buildings and public services in 1976 to that in 1977?
Provide a short and direct response. 1.05. What is the ratio of the CO2 emissions (% of total fuel combustion) in Resident buildings and public services in 1976 to that in 1978?
Your response must be concise. 0.76. What is the ratio of the CO2 emissions (% of total fuel combustion) of Transport in 1976 to that in 1978?
Ensure brevity in your answer.  0.99. What is the ratio of the CO2 emissions (% of total fuel combustion) of Other sectors in 1976 to that in 1979?
Your answer should be compact. 1.16. What is the ratio of the CO2 emissions (% of total fuel combustion) of Resident buildings and public services in 1976 to that in 1979?
Offer a terse response. 0.77. What is the ratio of the CO2 emissions (% of total fuel combustion) of Transport in 1976 to that in 1979?
Provide a succinct answer. 0.94. What is the ratio of the CO2 emissions (% of total fuel combustion) of Other sectors in 1976 to that in 1980?
Offer a terse response. 1.09. What is the ratio of the CO2 emissions (% of total fuel combustion) in Resident buildings and public services in 1976 to that in 1980?
Give a very brief answer. 0.73. What is the ratio of the CO2 emissions (% of total fuel combustion) of Transport in 1976 to that in 1980?
Your answer should be compact. 0.91. What is the ratio of the CO2 emissions (% of total fuel combustion) of Resident buildings and public services in 1976 to that in 1981?
Your response must be concise. 0.62. What is the ratio of the CO2 emissions (% of total fuel combustion) of Transport in 1976 to that in 1981?
Your answer should be very brief. 0.77. What is the ratio of the CO2 emissions (% of total fuel combustion) of Other sectors in 1976 to that in 1982?
Keep it short and to the point. 1.18. What is the ratio of the CO2 emissions (% of total fuel combustion) in Resident buildings and public services in 1976 to that in 1982?
Your answer should be compact. 0.59. What is the ratio of the CO2 emissions (% of total fuel combustion) in Transport in 1976 to that in 1982?
Provide a succinct answer. 0.98. What is the ratio of the CO2 emissions (% of total fuel combustion) in Other sectors in 1976 to that in 1983?
Offer a very short reply. 1.32. What is the ratio of the CO2 emissions (% of total fuel combustion) in Resident buildings and public services in 1976 to that in 1983?
Give a very brief answer. 0.66. What is the ratio of the CO2 emissions (% of total fuel combustion) of Transport in 1976 to that in 1983?
Make the answer very short. 1.14. What is the ratio of the CO2 emissions (% of total fuel combustion) in Other sectors in 1976 to that in 1984?
Provide a short and direct response. 1.38. What is the ratio of the CO2 emissions (% of total fuel combustion) in Resident buildings and public services in 1976 to that in 1984?
Give a very brief answer. 0.55. What is the ratio of the CO2 emissions (% of total fuel combustion) in Transport in 1976 to that in 1984?
Ensure brevity in your answer.  1.15. What is the ratio of the CO2 emissions (% of total fuel combustion) in Other sectors in 1977 to that in 1978?
Offer a terse response. 1.08. What is the ratio of the CO2 emissions (% of total fuel combustion) of Resident buildings and public services in 1977 to that in 1978?
Your answer should be very brief. 0.72. What is the ratio of the CO2 emissions (% of total fuel combustion) of Transport in 1977 to that in 1978?
Keep it short and to the point. 0.97. What is the ratio of the CO2 emissions (% of total fuel combustion) of Other sectors in 1977 to that in 1979?
Your response must be concise. 1.1. What is the ratio of the CO2 emissions (% of total fuel combustion) in Resident buildings and public services in 1977 to that in 1979?
Provide a short and direct response. 0.73. What is the ratio of the CO2 emissions (% of total fuel combustion) of Transport in 1977 to that in 1979?
Make the answer very short. 0.92. What is the ratio of the CO2 emissions (% of total fuel combustion) of Other sectors in 1977 to that in 1980?
Your response must be concise. 1.03. What is the ratio of the CO2 emissions (% of total fuel combustion) in Resident buildings and public services in 1977 to that in 1980?
Keep it short and to the point. 0.69. What is the ratio of the CO2 emissions (% of total fuel combustion) in Transport in 1977 to that in 1980?
Make the answer very short. 0.9. What is the ratio of the CO2 emissions (% of total fuel combustion) of Other sectors in 1977 to that in 1981?
Your response must be concise. 0.88. What is the ratio of the CO2 emissions (% of total fuel combustion) in Resident buildings and public services in 1977 to that in 1981?
Your answer should be compact. 0.59. What is the ratio of the CO2 emissions (% of total fuel combustion) in Transport in 1977 to that in 1981?
Give a very brief answer. 0.76. What is the ratio of the CO2 emissions (% of total fuel combustion) of Other sectors in 1977 to that in 1982?
Your response must be concise. 1.12. What is the ratio of the CO2 emissions (% of total fuel combustion) of Resident buildings and public services in 1977 to that in 1982?
Give a very brief answer. 0.56. What is the ratio of the CO2 emissions (% of total fuel combustion) in Transport in 1977 to that in 1982?
Ensure brevity in your answer.  0.97. What is the ratio of the CO2 emissions (% of total fuel combustion) in Other sectors in 1977 to that in 1983?
Offer a terse response. 1.25. What is the ratio of the CO2 emissions (% of total fuel combustion) of Resident buildings and public services in 1977 to that in 1983?
Offer a very short reply. 0.63. What is the ratio of the CO2 emissions (% of total fuel combustion) in Transport in 1977 to that in 1983?
Keep it short and to the point. 1.12. What is the ratio of the CO2 emissions (% of total fuel combustion) of Other sectors in 1977 to that in 1984?
Offer a terse response. 1.31. What is the ratio of the CO2 emissions (% of total fuel combustion) of Resident buildings and public services in 1977 to that in 1984?
Your answer should be very brief. 0.52. What is the ratio of the CO2 emissions (% of total fuel combustion) of Transport in 1977 to that in 1984?
Provide a short and direct response. 1.13. What is the ratio of the CO2 emissions (% of total fuel combustion) in Other sectors in 1978 to that in 1979?
Your answer should be very brief. 1.02. What is the ratio of the CO2 emissions (% of total fuel combustion) in Resident buildings and public services in 1978 to that in 1979?
Your response must be concise. 1.02. What is the ratio of the CO2 emissions (% of total fuel combustion) in Transport in 1978 to that in 1979?
Provide a succinct answer. 0.95. What is the ratio of the CO2 emissions (% of total fuel combustion) of Other sectors in 1978 to that in 1980?
Offer a terse response. 0.95. What is the ratio of the CO2 emissions (% of total fuel combustion) of Resident buildings and public services in 1978 to that in 1980?
Your answer should be compact. 0.95. What is the ratio of the CO2 emissions (% of total fuel combustion) of Transport in 1978 to that in 1980?
Provide a short and direct response. 0.92. What is the ratio of the CO2 emissions (% of total fuel combustion) in Other sectors in 1978 to that in 1981?
Keep it short and to the point. 0.81. What is the ratio of the CO2 emissions (% of total fuel combustion) of Resident buildings and public services in 1978 to that in 1981?
Make the answer very short. 0.81. What is the ratio of the CO2 emissions (% of total fuel combustion) of Transport in 1978 to that in 1981?
Offer a very short reply. 0.79. What is the ratio of the CO2 emissions (% of total fuel combustion) of Other sectors in 1978 to that in 1982?
Your response must be concise. 1.03. What is the ratio of the CO2 emissions (% of total fuel combustion) of Resident buildings and public services in 1978 to that in 1982?
Your answer should be compact. 0.77. What is the ratio of the CO2 emissions (% of total fuel combustion) of Transport in 1978 to that in 1982?
Provide a succinct answer. 1. What is the ratio of the CO2 emissions (% of total fuel combustion) of Other sectors in 1978 to that in 1983?
Your response must be concise. 1.16. What is the ratio of the CO2 emissions (% of total fuel combustion) of Resident buildings and public services in 1978 to that in 1983?
Keep it short and to the point. 0.87. What is the ratio of the CO2 emissions (% of total fuel combustion) in Transport in 1978 to that in 1983?
Your answer should be compact. 1.16. What is the ratio of the CO2 emissions (% of total fuel combustion) of Other sectors in 1978 to that in 1984?
Your answer should be very brief. 1.2. What is the ratio of the CO2 emissions (% of total fuel combustion) in Resident buildings and public services in 1978 to that in 1984?
Provide a short and direct response. 0.72. What is the ratio of the CO2 emissions (% of total fuel combustion) in Transport in 1978 to that in 1984?
Ensure brevity in your answer.  1.16. What is the ratio of the CO2 emissions (% of total fuel combustion) in Other sectors in 1979 to that in 1980?
Your answer should be compact. 0.94. What is the ratio of the CO2 emissions (% of total fuel combustion) of Resident buildings and public services in 1979 to that in 1980?
Give a very brief answer. 0.94. What is the ratio of the CO2 emissions (% of total fuel combustion) in Transport in 1979 to that in 1980?
Provide a short and direct response. 0.97. What is the ratio of the CO2 emissions (% of total fuel combustion) in Other sectors in 1979 to that in 1981?
Offer a terse response. 0.8. What is the ratio of the CO2 emissions (% of total fuel combustion) in Transport in 1979 to that in 1981?
Ensure brevity in your answer.  0.83. What is the ratio of the CO2 emissions (% of total fuel combustion) in Other sectors in 1979 to that in 1982?
Make the answer very short. 1.02. What is the ratio of the CO2 emissions (% of total fuel combustion) of Resident buildings and public services in 1979 to that in 1982?
Make the answer very short. 0.76. What is the ratio of the CO2 emissions (% of total fuel combustion) of Transport in 1979 to that in 1982?
Make the answer very short. 1.05. What is the ratio of the CO2 emissions (% of total fuel combustion) of Other sectors in 1979 to that in 1983?
Offer a very short reply. 1.14. What is the ratio of the CO2 emissions (% of total fuel combustion) in Resident buildings and public services in 1979 to that in 1983?
Offer a very short reply. 0.85. What is the ratio of the CO2 emissions (% of total fuel combustion) of Transport in 1979 to that in 1983?
Provide a short and direct response. 1.22. What is the ratio of the CO2 emissions (% of total fuel combustion) of Other sectors in 1979 to that in 1984?
Give a very brief answer. 1.18. What is the ratio of the CO2 emissions (% of total fuel combustion) of Resident buildings and public services in 1979 to that in 1984?
Your answer should be compact. 0.71. What is the ratio of the CO2 emissions (% of total fuel combustion) in Transport in 1979 to that in 1984?
Offer a very short reply. 1.22. What is the ratio of the CO2 emissions (% of total fuel combustion) in Other sectors in 1980 to that in 1981?
Provide a succinct answer. 0.85. What is the ratio of the CO2 emissions (% of total fuel combustion) in Resident buildings and public services in 1980 to that in 1981?
Offer a very short reply. 0.85. What is the ratio of the CO2 emissions (% of total fuel combustion) in Transport in 1980 to that in 1981?
Your answer should be very brief. 0.85. What is the ratio of the CO2 emissions (% of total fuel combustion) of Other sectors in 1980 to that in 1982?
Provide a succinct answer. 1.08. What is the ratio of the CO2 emissions (% of total fuel combustion) in Resident buildings and public services in 1980 to that in 1982?
Give a very brief answer. 0.81. What is the ratio of the CO2 emissions (% of total fuel combustion) of Transport in 1980 to that in 1982?
Give a very brief answer. 1.08. What is the ratio of the CO2 emissions (% of total fuel combustion) of Other sectors in 1980 to that in 1983?
Give a very brief answer. 1.21. What is the ratio of the CO2 emissions (% of total fuel combustion) in Resident buildings and public services in 1980 to that in 1983?
Ensure brevity in your answer.  0.91. What is the ratio of the CO2 emissions (% of total fuel combustion) in Transport in 1980 to that in 1983?
Provide a succinct answer. 1.25. What is the ratio of the CO2 emissions (% of total fuel combustion) of Other sectors in 1980 to that in 1984?
Your answer should be compact. 1.26. What is the ratio of the CO2 emissions (% of total fuel combustion) in Resident buildings and public services in 1980 to that in 1984?
Your answer should be compact. 0.76. What is the ratio of the CO2 emissions (% of total fuel combustion) in Transport in 1980 to that in 1984?
Your answer should be compact. 1.26. What is the ratio of the CO2 emissions (% of total fuel combustion) in Other sectors in 1981 to that in 1982?
Your answer should be very brief. 1.27. What is the ratio of the CO2 emissions (% of total fuel combustion) in Resident buildings and public services in 1981 to that in 1982?
Provide a short and direct response. 0.95. What is the ratio of the CO2 emissions (% of total fuel combustion) in Transport in 1981 to that in 1982?
Provide a succinct answer. 1.27. What is the ratio of the CO2 emissions (% of total fuel combustion) of Other sectors in 1981 to that in 1983?
Your answer should be compact. 1.42. What is the ratio of the CO2 emissions (% of total fuel combustion) in Resident buildings and public services in 1981 to that in 1983?
Offer a terse response. 1.07. What is the ratio of the CO2 emissions (% of total fuel combustion) of Transport in 1981 to that in 1983?
Make the answer very short. 1.47. What is the ratio of the CO2 emissions (% of total fuel combustion) in Other sectors in 1981 to that in 1984?
Keep it short and to the point. 1.48. What is the ratio of the CO2 emissions (% of total fuel combustion) of Resident buildings and public services in 1981 to that in 1984?
Offer a very short reply. 0.89. What is the ratio of the CO2 emissions (% of total fuel combustion) in Transport in 1981 to that in 1984?
Make the answer very short. 1.48. What is the ratio of the CO2 emissions (% of total fuel combustion) in Other sectors in 1982 to that in 1983?
Offer a terse response. 1.12. What is the ratio of the CO2 emissions (% of total fuel combustion) of Resident buildings and public services in 1982 to that in 1983?
Make the answer very short. 1.12. What is the ratio of the CO2 emissions (% of total fuel combustion) in Transport in 1982 to that in 1983?
Your answer should be very brief. 1.16. What is the ratio of the CO2 emissions (% of total fuel combustion) of Other sectors in 1982 to that in 1984?
Your answer should be compact. 1.17. What is the ratio of the CO2 emissions (% of total fuel combustion) of Other sectors in 1983 to that in 1984?
Your answer should be very brief. 1.04. What is the ratio of the CO2 emissions (% of total fuel combustion) of Resident buildings and public services in 1983 to that in 1984?
Keep it short and to the point. 0.83. What is the ratio of the CO2 emissions (% of total fuel combustion) of Transport in 1983 to that in 1984?
Provide a succinct answer. 1.01. What is the difference between the highest and the second highest CO2 emissions (% of total fuel combustion) in Other sectors?
Ensure brevity in your answer.  0.14. What is the difference between the highest and the second highest CO2 emissions (% of total fuel combustion) of Resident buildings and public services?
Provide a short and direct response. 0.43. What is the difference between the highest and the second highest CO2 emissions (% of total fuel combustion) of Transport?
Your response must be concise. 8.51. What is the difference between the highest and the lowest CO2 emissions (% of total fuel combustion) in Other sectors?
Provide a succinct answer. 0.62. What is the difference between the highest and the lowest CO2 emissions (% of total fuel combustion) in Resident buildings and public services?
Keep it short and to the point. 3.1. What is the difference between the highest and the lowest CO2 emissions (% of total fuel combustion) of Transport?
Keep it short and to the point. 18.73. 